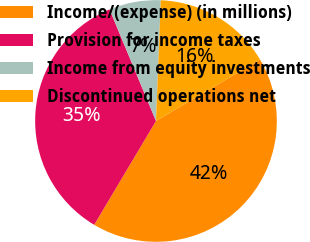Convert chart. <chart><loc_0><loc_0><loc_500><loc_500><pie_chart><fcel>Income/(expense) (in millions)<fcel>Provision for income taxes<fcel>Income from equity investments<fcel>Discontinued operations net<nl><fcel>42.05%<fcel>35.18%<fcel>6.91%<fcel>15.87%<nl></chart> 